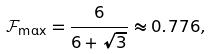Convert formula to latex. <formula><loc_0><loc_0><loc_500><loc_500>\mathcal { F } _ { \max } = \frac { 6 } { 6 + \sqrt { 3 } } \approx 0 . 7 7 6 ,</formula> 